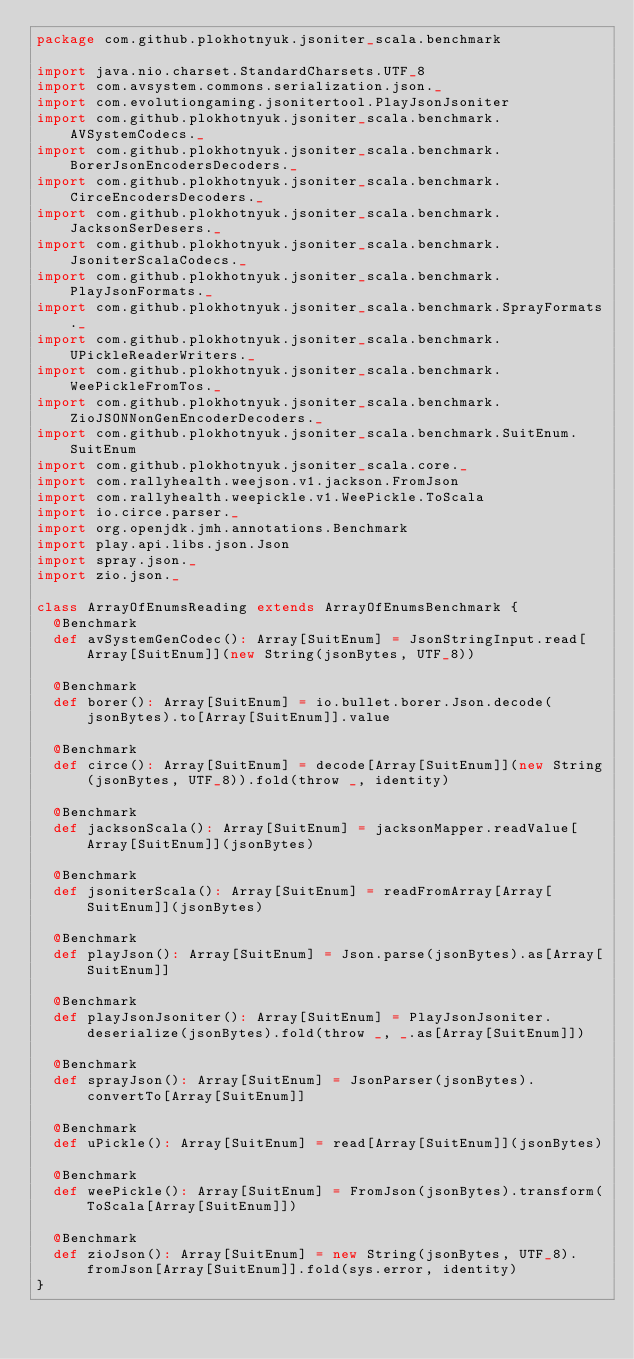Convert code to text. <code><loc_0><loc_0><loc_500><loc_500><_Scala_>package com.github.plokhotnyuk.jsoniter_scala.benchmark

import java.nio.charset.StandardCharsets.UTF_8
import com.avsystem.commons.serialization.json._
import com.evolutiongaming.jsonitertool.PlayJsonJsoniter
import com.github.plokhotnyuk.jsoniter_scala.benchmark.AVSystemCodecs._
import com.github.plokhotnyuk.jsoniter_scala.benchmark.BorerJsonEncodersDecoders._
import com.github.plokhotnyuk.jsoniter_scala.benchmark.CirceEncodersDecoders._
import com.github.plokhotnyuk.jsoniter_scala.benchmark.JacksonSerDesers._
import com.github.plokhotnyuk.jsoniter_scala.benchmark.JsoniterScalaCodecs._
import com.github.plokhotnyuk.jsoniter_scala.benchmark.PlayJsonFormats._
import com.github.plokhotnyuk.jsoniter_scala.benchmark.SprayFormats._
import com.github.plokhotnyuk.jsoniter_scala.benchmark.UPickleReaderWriters._
import com.github.plokhotnyuk.jsoniter_scala.benchmark.WeePickleFromTos._
import com.github.plokhotnyuk.jsoniter_scala.benchmark.ZioJSONNonGenEncoderDecoders._
import com.github.plokhotnyuk.jsoniter_scala.benchmark.SuitEnum.SuitEnum
import com.github.plokhotnyuk.jsoniter_scala.core._
import com.rallyhealth.weejson.v1.jackson.FromJson
import com.rallyhealth.weepickle.v1.WeePickle.ToScala
import io.circe.parser._
import org.openjdk.jmh.annotations.Benchmark
import play.api.libs.json.Json
import spray.json._
import zio.json._

class ArrayOfEnumsReading extends ArrayOfEnumsBenchmark {
  @Benchmark
  def avSystemGenCodec(): Array[SuitEnum] = JsonStringInput.read[Array[SuitEnum]](new String(jsonBytes, UTF_8))

  @Benchmark
  def borer(): Array[SuitEnum] = io.bullet.borer.Json.decode(jsonBytes).to[Array[SuitEnum]].value

  @Benchmark
  def circe(): Array[SuitEnum] = decode[Array[SuitEnum]](new String(jsonBytes, UTF_8)).fold(throw _, identity)

  @Benchmark
  def jacksonScala(): Array[SuitEnum] = jacksonMapper.readValue[Array[SuitEnum]](jsonBytes)

  @Benchmark
  def jsoniterScala(): Array[SuitEnum] = readFromArray[Array[SuitEnum]](jsonBytes)

  @Benchmark
  def playJson(): Array[SuitEnum] = Json.parse(jsonBytes).as[Array[SuitEnum]]

  @Benchmark
  def playJsonJsoniter(): Array[SuitEnum] = PlayJsonJsoniter.deserialize(jsonBytes).fold(throw _, _.as[Array[SuitEnum]])

  @Benchmark
  def sprayJson(): Array[SuitEnum] = JsonParser(jsonBytes).convertTo[Array[SuitEnum]]

  @Benchmark
  def uPickle(): Array[SuitEnum] = read[Array[SuitEnum]](jsonBytes)

  @Benchmark
  def weePickle(): Array[SuitEnum] = FromJson(jsonBytes).transform(ToScala[Array[SuitEnum]])

  @Benchmark
  def zioJson(): Array[SuitEnum] = new String(jsonBytes, UTF_8).fromJson[Array[SuitEnum]].fold(sys.error, identity)
}</code> 